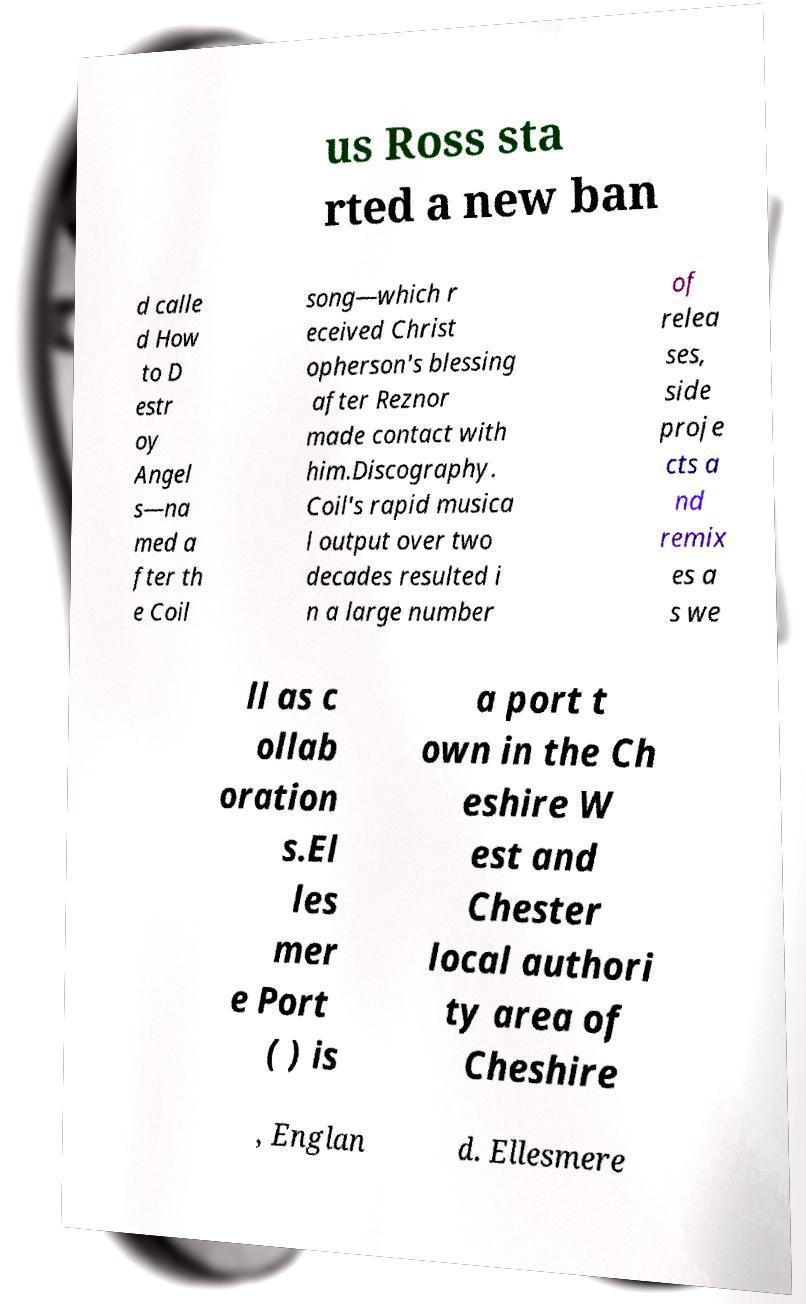Please read and relay the text visible in this image. What does it say? us Ross sta rted a new ban d calle d How to D estr oy Angel s—na med a fter th e Coil song—which r eceived Christ opherson's blessing after Reznor made contact with him.Discography. Coil's rapid musica l output over two decades resulted i n a large number of relea ses, side proje cts a nd remix es a s we ll as c ollab oration s.El les mer e Port ( ) is a port t own in the Ch eshire W est and Chester local authori ty area of Cheshire , Englan d. Ellesmere 